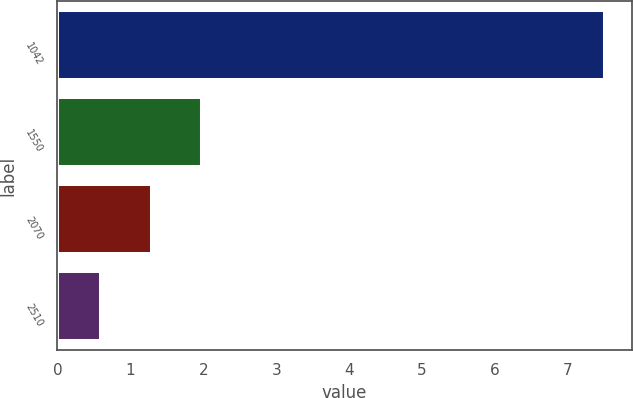Convert chart. <chart><loc_0><loc_0><loc_500><loc_500><bar_chart><fcel>1042<fcel>1550<fcel>2070<fcel>2510<nl><fcel>7.5<fcel>1.98<fcel>1.29<fcel>0.6<nl></chart> 